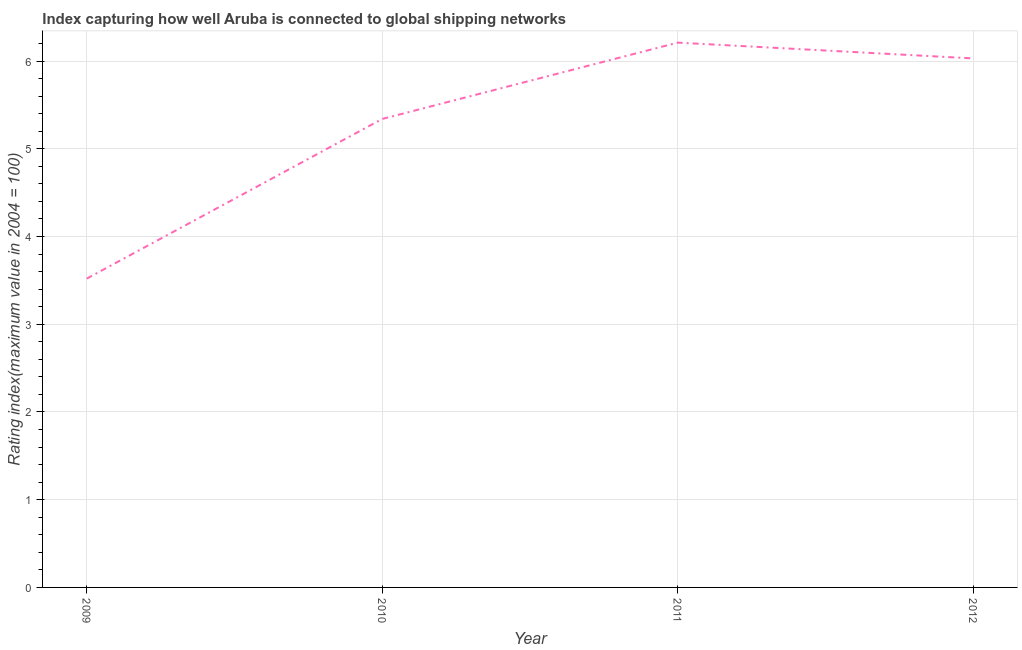What is the liner shipping connectivity index in 2009?
Keep it short and to the point. 3.52. Across all years, what is the maximum liner shipping connectivity index?
Provide a short and direct response. 6.21. Across all years, what is the minimum liner shipping connectivity index?
Offer a very short reply. 3.52. In which year was the liner shipping connectivity index maximum?
Your response must be concise. 2011. What is the sum of the liner shipping connectivity index?
Your answer should be very brief. 21.1. What is the difference between the liner shipping connectivity index in 2011 and 2012?
Provide a succinct answer. 0.18. What is the average liner shipping connectivity index per year?
Your response must be concise. 5.28. What is the median liner shipping connectivity index?
Your answer should be very brief. 5.69. In how many years, is the liner shipping connectivity index greater than 0.4 ?
Offer a terse response. 4. Do a majority of the years between 2009 and 2010 (inclusive) have liner shipping connectivity index greater than 2.2 ?
Provide a succinct answer. Yes. What is the ratio of the liner shipping connectivity index in 2009 to that in 2010?
Keep it short and to the point. 0.66. Is the difference between the liner shipping connectivity index in 2009 and 2012 greater than the difference between any two years?
Make the answer very short. No. What is the difference between the highest and the second highest liner shipping connectivity index?
Ensure brevity in your answer.  0.18. What is the difference between the highest and the lowest liner shipping connectivity index?
Make the answer very short. 2.69. How many years are there in the graph?
Make the answer very short. 4. Are the values on the major ticks of Y-axis written in scientific E-notation?
Make the answer very short. No. Does the graph contain any zero values?
Your response must be concise. No. Does the graph contain grids?
Your answer should be very brief. Yes. What is the title of the graph?
Provide a short and direct response. Index capturing how well Aruba is connected to global shipping networks. What is the label or title of the Y-axis?
Your answer should be very brief. Rating index(maximum value in 2004 = 100). What is the Rating index(maximum value in 2004 = 100) in 2009?
Make the answer very short. 3.52. What is the Rating index(maximum value in 2004 = 100) of 2010?
Keep it short and to the point. 5.34. What is the Rating index(maximum value in 2004 = 100) in 2011?
Ensure brevity in your answer.  6.21. What is the Rating index(maximum value in 2004 = 100) in 2012?
Make the answer very short. 6.03. What is the difference between the Rating index(maximum value in 2004 = 100) in 2009 and 2010?
Ensure brevity in your answer.  -1.82. What is the difference between the Rating index(maximum value in 2004 = 100) in 2009 and 2011?
Give a very brief answer. -2.69. What is the difference between the Rating index(maximum value in 2004 = 100) in 2009 and 2012?
Offer a very short reply. -2.51. What is the difference between the Rating index(maximum value in 2004 = 100) in 2010 and 2011?
Your answer should be very brief. -0.87. What is the difference between the Rating index(maximum value in 2004 = 100) in 2010 and 2012?
Your answer should be compact. -0.69. What is the difference between the Rating index(maximum value in 2004 = 100) in 2011 and 2012?
Your response must be concise. 0.18. What is the ratio of the Rating index(maximum value in 2004 = 100) in 2009 to that in 2010?
Keep it short and to the point. 0.66. What is the ratio of the Rating index(maximum value in 2004 = 100) in 2009 to that in 2011?
Your answer should be very brief. 0.57. What is the ratio of the Rating index(maximum value in 2004 = 100) in 2009 to that in 2012?
Your answer should be compact. 0.58. What is the ratio of the Rating index(maximum value in 2004 = 100) in 2010 to that in 2011?
Give a very brief answer. 0.86. What is the ratio of the Rating index(maximum value in 2004 = 100) in 2010 to that in 2012?
Your response must be concise. 0.89. 